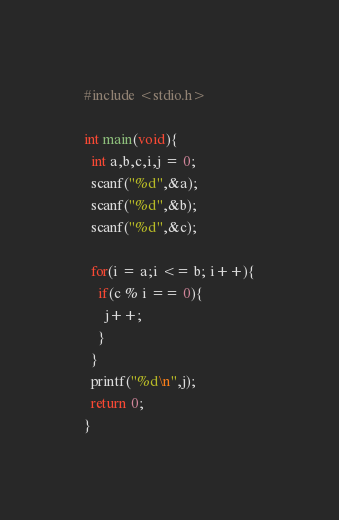<code> <loc_0><loc_0><loc_500><loc_500><_C_>#include <stdio.h>

int main(void){
  int a,b,c,i,j = 0;
  scanf("%d",&a);
  scanf("%d",&b);
  scanf("%d",&c);

  for(i = a;i <= b; i++){
    if(c % i == 0){
      j++;
    }
  }
  printf("%d\n",j);
  return 0;
}
</code> 